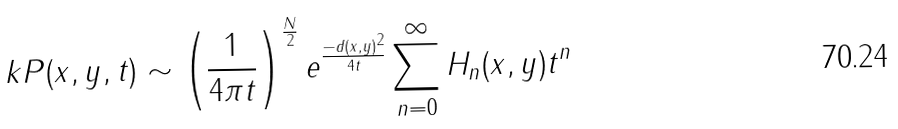<formula> <loc_0><loc_0><loc_500><loc_500>\ k P ( x , y , t ) \sim \left ( \frac { 1 } { 4 \pi t } \right ) ^ { \frac { N } { 2 } } e ^ { \frac { - d ( x , y ) ^ { 2 } } { 4 t } } \sum _ { n = 0 } ^ { \infty } H _ { n } ( x , y ) t ^ { n }</formula> 